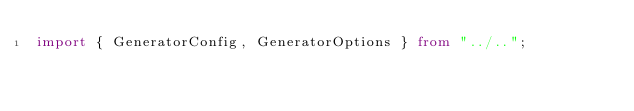Convert code to text. <code><loc_0><loc_0><loc_500><loc_500><_TypeScript_>import { GeneratorConfig, GeneratorOptions } from "../..";</code> 